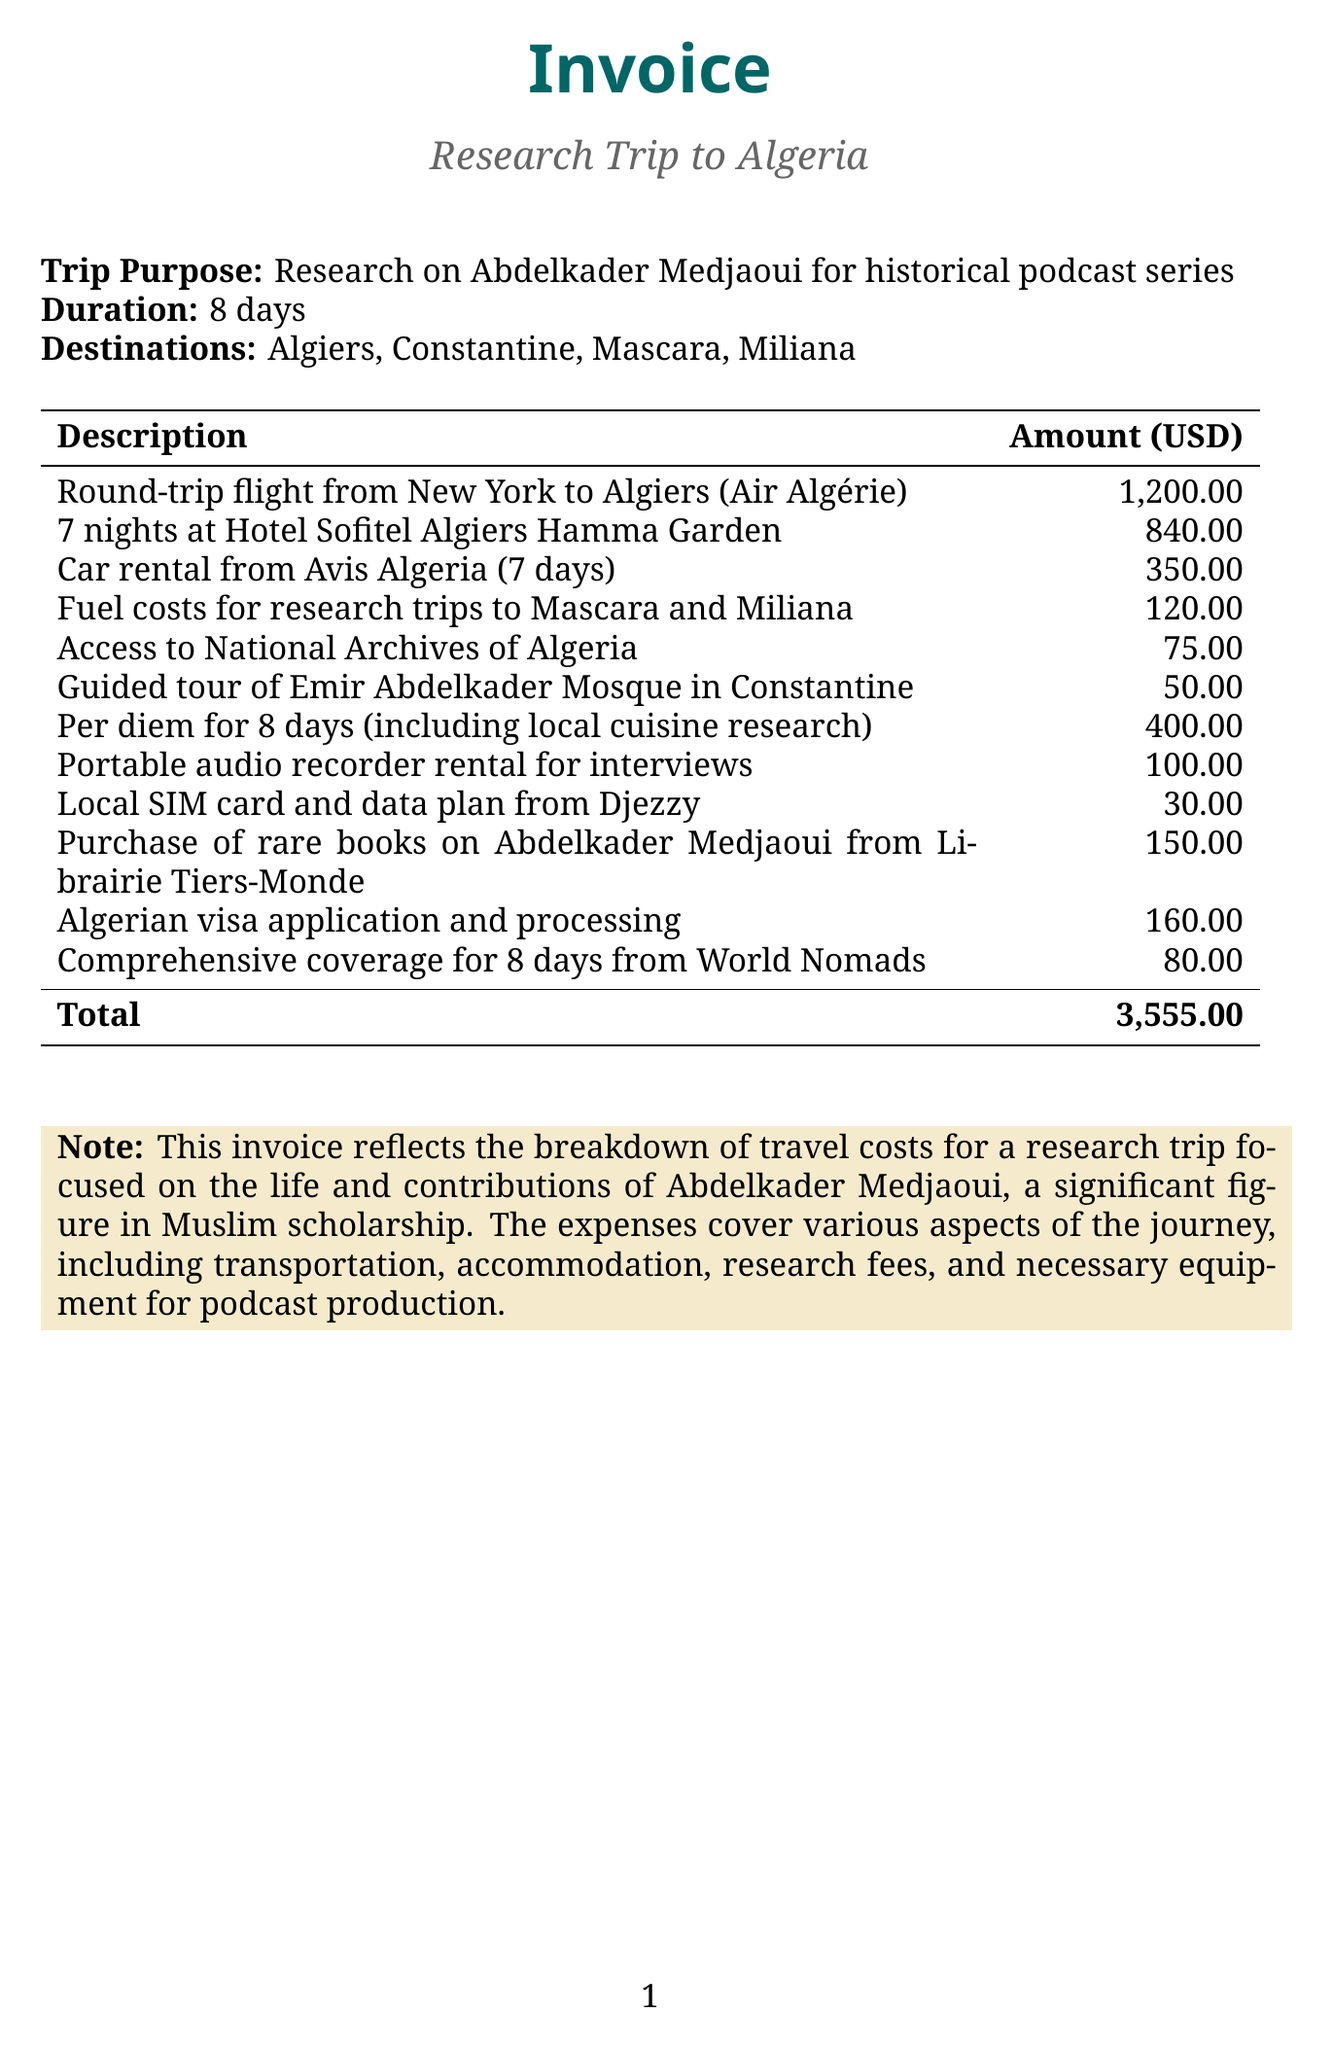What is the total amount of the invoice? The total amount is provided at the bottom of the invoice, which sums all the expenses listed.
Answer: 3,555.00 What is the purpose of the trip? The purpose of the trip is stated in the document, reflecting the focus of the research activities.
Answer: Research on Abdelkader Medjaoui for historical podcast series How many nights was the accommodation booked for? The invoice specifies the duration of stay at the hotel mentioned in the accommodation category.
Answer: 7 nights What type of transportation was used for the research trip? The types of transportation are detailed under the local transportation category, showing the means of transport utilized.
Answer: Car rental What was the cost of the guided tour of the Emir Abdelkader Mosque? The price of the guided tour is explicitly listed among the research fees in the invoice.
Answer: 50.00 What was included in the per diem for meals? The per diem description notes that it covers food expenses and research related to local cuisine.
Answer: Local cuisine research Who provided the local SIM card and data plan? The invoice mentions the company that supplied the communication services for the trip.
Answer: Djezzy What document is being summarized in this invoice? The title section and other details indicate the nature of the document and its purpose.
Answer: Invoice What is the duration of the trip? The document specifies the total duration of the research trip in terms of days.
Answer: 8 days 